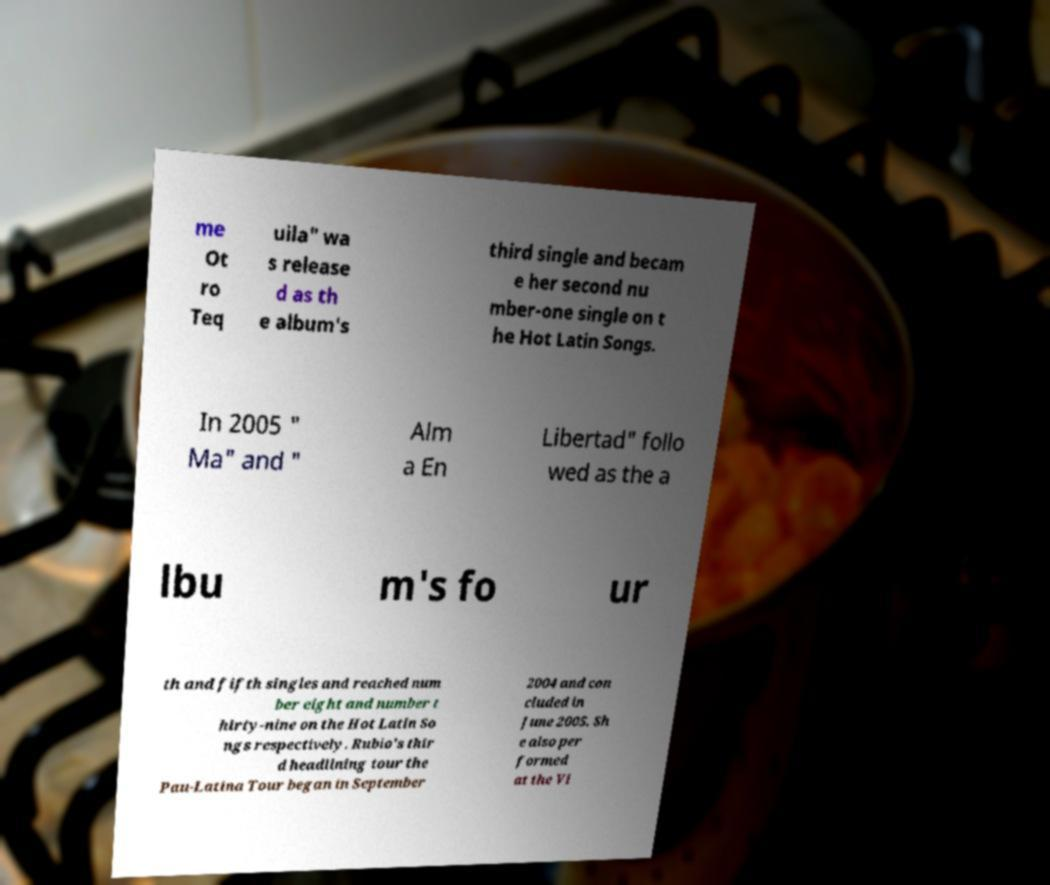Can you read and provide the text displayed in the image?This photo seems to have some interesting text. Can you extract and type it out for me? me Ot ro Teq uila" wa s release d as th e album's third single and becam e her second nu mber-one single on t he Hot Latin Songs. In 2005 " Ma" and " Alm a En Libertad" follo wed as the a lbu m's fo ur th and fifth singles and reached num ber eight and number t hirty-nine on the Hot Latin So ngs respectively. Rubio's thir d headlining tour the Pau-Latina Tour began in September 2004 and con cluded in June 2005. Sh e also per formed at the Vi 